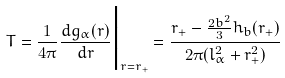<formula> <loc_0><loc_0><loc_500><loc_500>T = \frac { 1 } { 4 \pi } \frac { d g _ { \alpha } ( r ) } { d r } \Big { | } _ { r = r _ { + } } = \frac { r _ { + } - \frac { 2 b ^ { 2 } } { 3 } h _ { b } ( r _ { + } ) } { 2 \pi ( l _ { \alpha } ^ { 2 } + r _ { + } ^ { 2 } ) }</formula> 